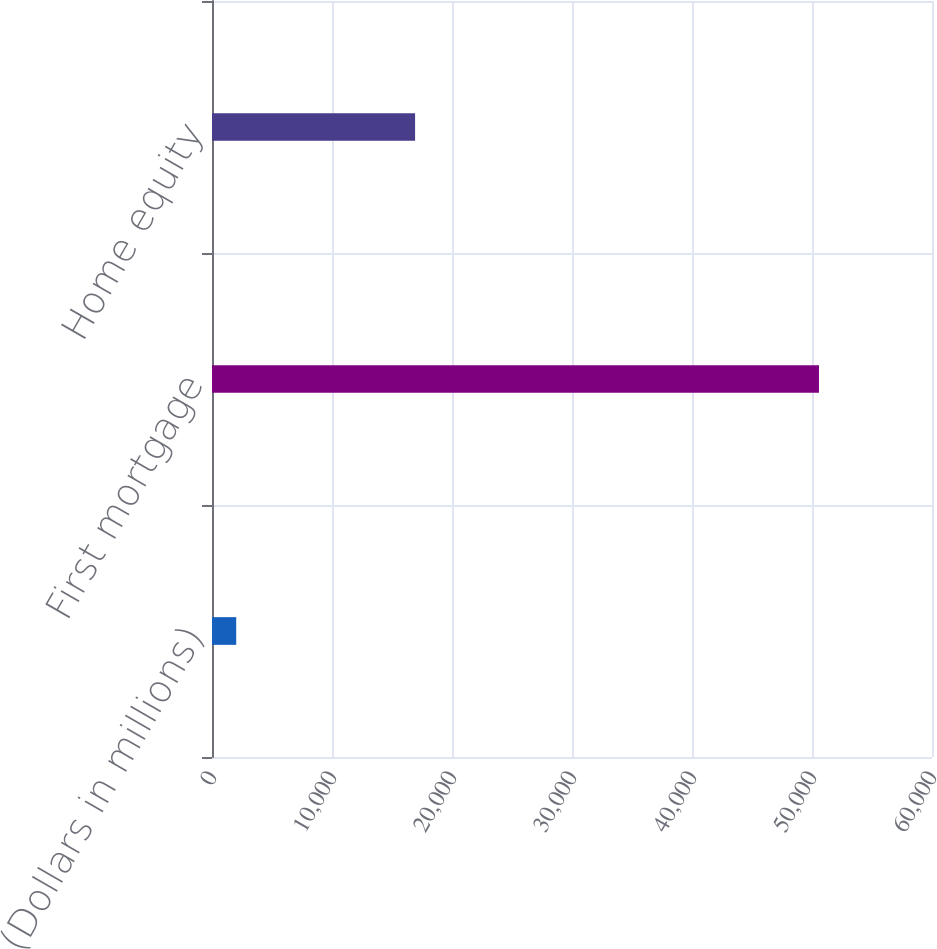<chart> <loc_0><loc_0><loc_500><loc_500><bar_chart><fcel>(Dollars in millions)<fcel>First mortgage<fcel>Home equity<nl><fcel>2017<fcel>50581<fcel>16924<nl></chart> 